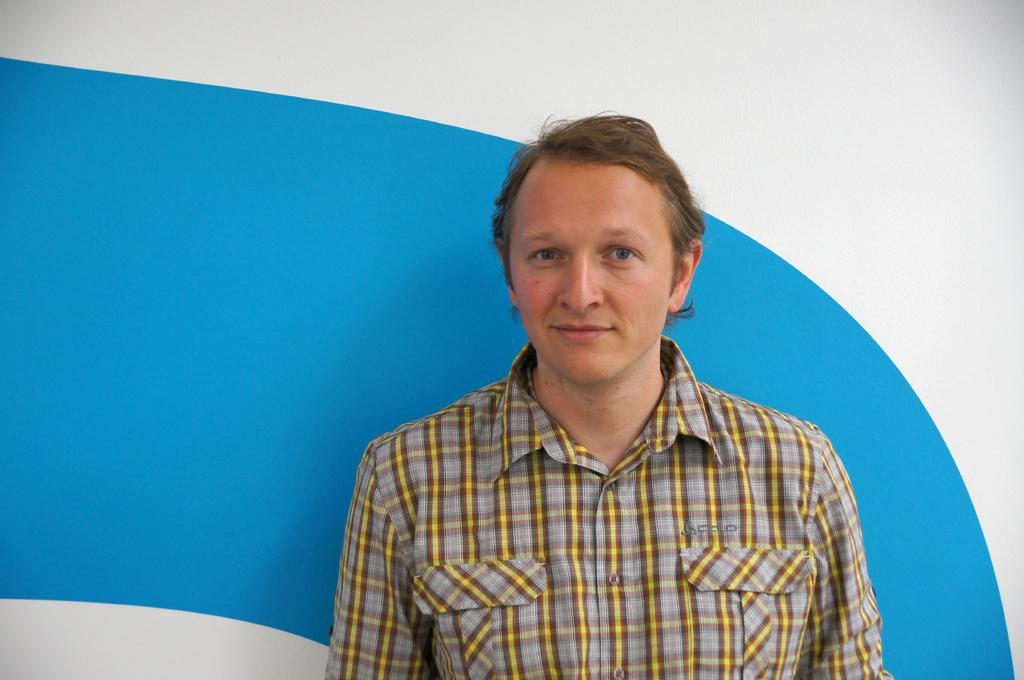What is the main subject in the image? There is a man standing in the image. What can be seen in the background of the image? There is a wall in the background of the image. What colors are present on the wall in the image? The wall has blue and white colors. Can you see any squirrels making adjustments to the wall in the image? There are no squirrels present in the image, and therefore no such activity can be observed. 